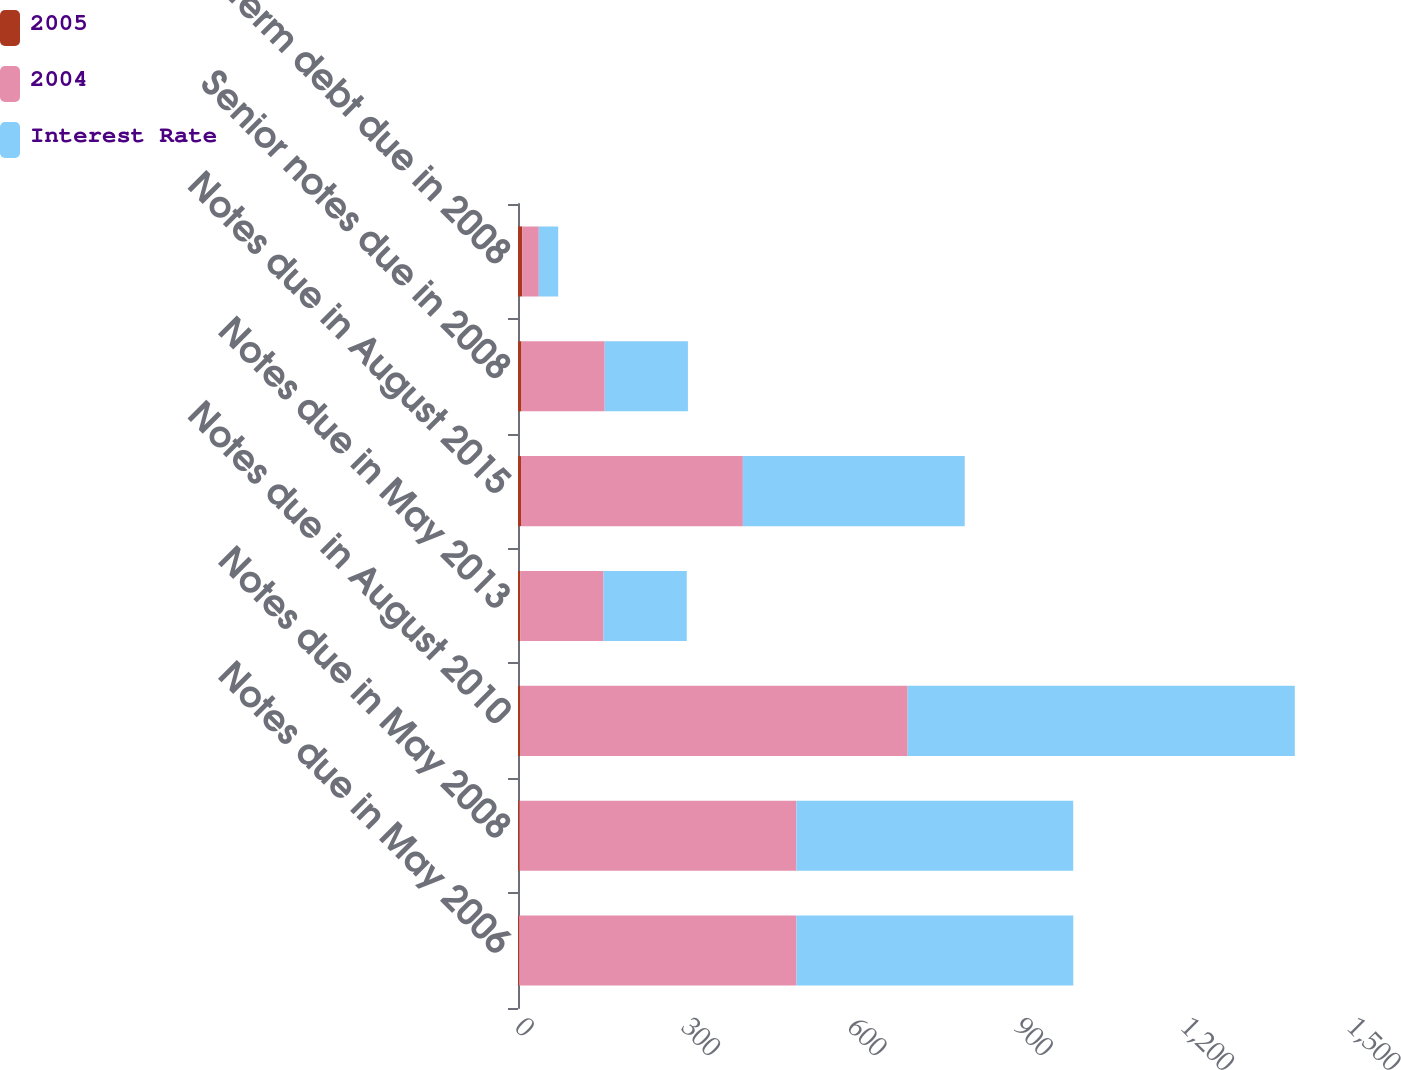Convert chart. <chart><loc_0><loc_0><loc_500><loc_500><stacked_bar_chart><ecel><fcel>Notes due in May 2006<fcel>Notes due in May 2008<fcel>Notes due in August 2010<fcel>Notes due in May 2013<fcel>Notes due in August 2015<fcel>Senior notes due in 2008<fcel>Term debt due in 2008<nl><fcel>2005<fcel>2.12<fcel>3<fcel>4.5<fcel>4.25<fcel>5.38<fcel>6.32<fcel>7.5<nl><fcel>2004<fcel>500<fcel>499<fcel>698<fcel>150<fcel>400<fcel>150<fcel>30<nl><fcel>Interest Rate<fcel>499<fcel>499<fcel>698<fcel>150<fcel>400<fcel>150<fcel>35<nl></chart> 